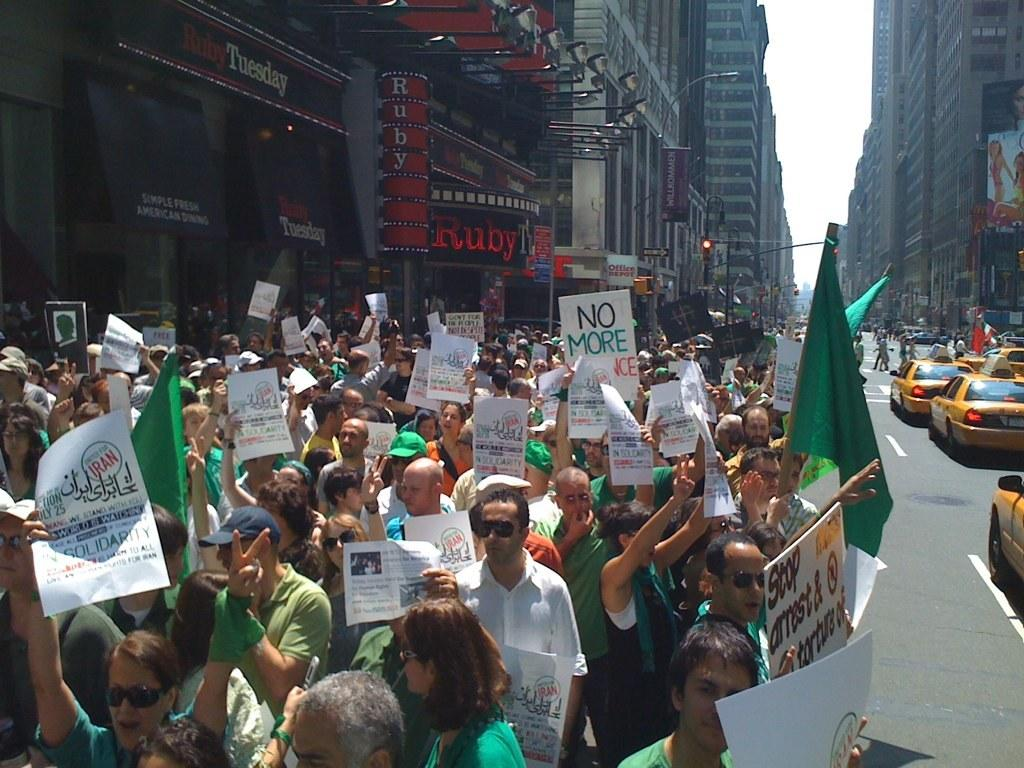<image>
Describe the image concisely. People with green flags and shirts in a protest with a sign that says NO MORE. 